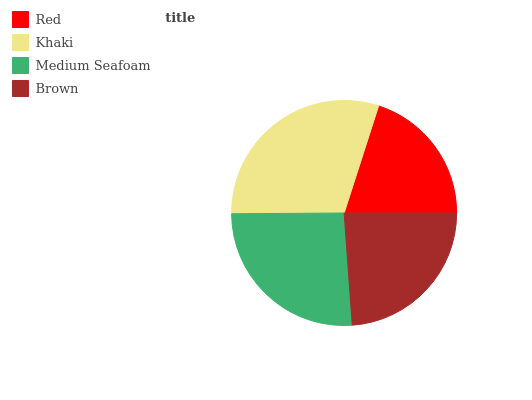Is Red the minimum?
Answer yes or no. Yes. Is Khaki the maximum?
Answer yes or no. Yes. Is Medium Seafoam the minimum?
Answer yes or no. No. Is Medium Seafoam the maximum?
Answer yes or no. No. Is Khaki greater than Medium Seafoam?
Answer yes or no. Yes. Is Medium Seafoam less than Khaki?
Answer yes or no. Yes. Is Medium Seafoam greater than Khaki?
Answer yes or no. No. Is Khaki less than Medium Seafoam?
Answer yes or no. No. Is Medium Seafoam the high median?
Answer yes or no. Yes. Is Brown the low median?
Answer yes or no. Yes. Is Khaki the high median?
Answer yes or no. No. Is Red the low median?
Answer yes or no. No. 